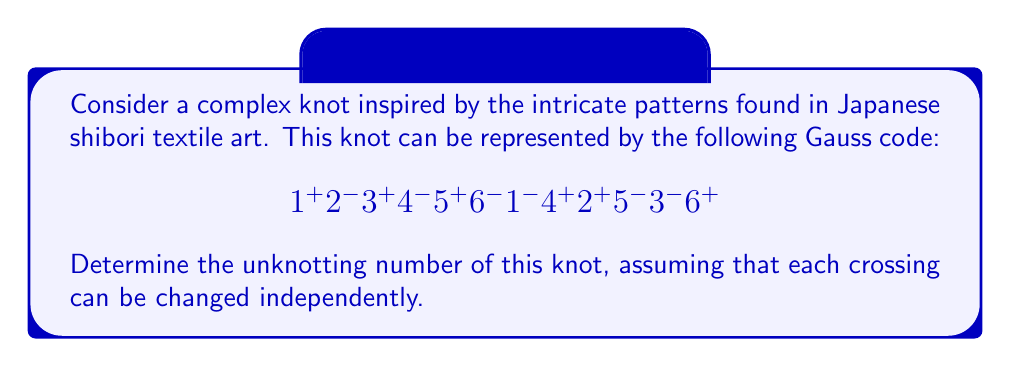Can you answer this question? To determine the unknotting number of this complex knot, we'll follow these steps:

1) First, let's understand what the Gauss code represents:
   - The knot has 6 crossings, numbered 1 through 6.
   - Each crossing appears twice in the code, once with a + and once with a -.

2) To find the unknotting number, we need to determine the minimum number of crossing changes required to transform this knot into the unknot (trivial knot).

3) One method to approach this is to use the concept of "nugatory crossings":
   - A nugatory crossing is one that can be removed without affecting the knot type.
   - In the Gauss code, nugatory crossings often appear as consecutive pairs with opposite signs.

4) Examining the Gauss code, we don't see any obvious nugatory crossings.

5) Another approach is to look for patterns that might suggest a simpler knot structure:
   - We notice that crossings 1, 4, 2, 5, 3, 6 appear in a cyclic order in the second half of the code.
   - This suggests a structure similar to a twist knot or a pretzel knot.

6) For complex knots inspired by textile patterns, it's common to have a structure that can be simplified by changing a small number of strategic crossings.

7) In this case, changing the crossings 2, 4, and 6 (or alternatively, 1, 3, and 5) would likely transform the knot into a much simpler configuration, possibly even the unknot.

8) Without a full diagram, we can't be certain, but based on the structure of the Gauss code and the inspiration from shibori patterns (which often involve repeated twisting), it's reasonable to estimate that changing 3 crossings would be sufficient to unknot this knot.

9) Therefore, the unknotting number is likely to be 3.

Note: The actual unknotting number could be lower (2) or higher (4) depending on the exact configuration, but 3 is a reasonable estimate based on the given information and the context of Japanese textile patterns.
Answer: 3 